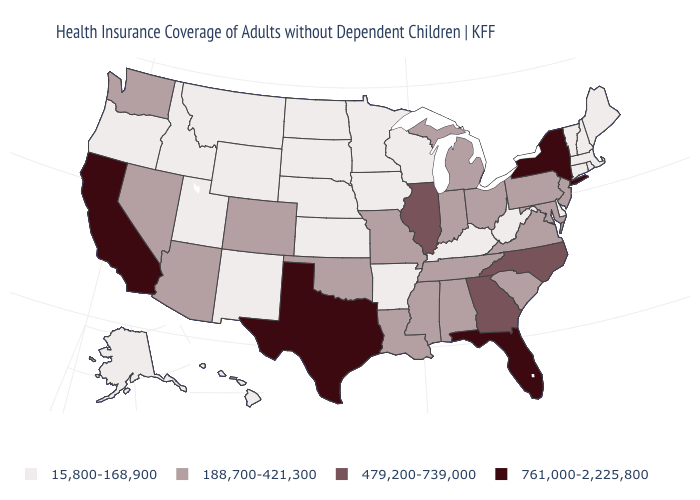What is the value of Connecticut?
Short answer required. 15,800-168,900. Is the legend a continuous bar?
Answer briefly. No. Does Hawaii have the lowest value in the USA?
Answer briefly. Yes. Name the states that have a value in the range 479,200-739,000?
Quick response, please. Georgia, Illinois, North Carolina. What is the value of Alabama?
Be succinct. 188,700-421,300. What is the value of Kansas?
Short answer required. 15,800-168,900. Name the states that have a value in the range 15,800-168,900?
Write a very short answer. Alaska, Arkansas, Connecticut, Delaware, Hawaii, Idaho, Iowa, Kansas, Kentucky, Maine, Massachusetts, Minnesota, Montana, Nebraska, New Hampshire, New Mexico, North Dakota, Oregon, Rhode Island, South Dakota, Utah, Vermont, West Virginia, Wisconsin, Wyoming. What is the highest value in states that border Illinois?
Short answer required. 188,700-421,300. Does Alabama have the lowest value in the USA?
Short answer required. No. Does South Carolina have a higher value than Oregon?
Keep it brief. Yes. Name the states that have a value in the range 479,200-739,000?
Be succinct. Georgia, Illinois, North Carolina. Among the states that border Washington , which have the highest value?
Concise answer only. Idaho, Oregon. Among the states that border New Jersey , which have the lowest value?
Keep it brief. Delaware. Does the first symbol in the legend represent the smallest category?
Short answer required. Yes. 